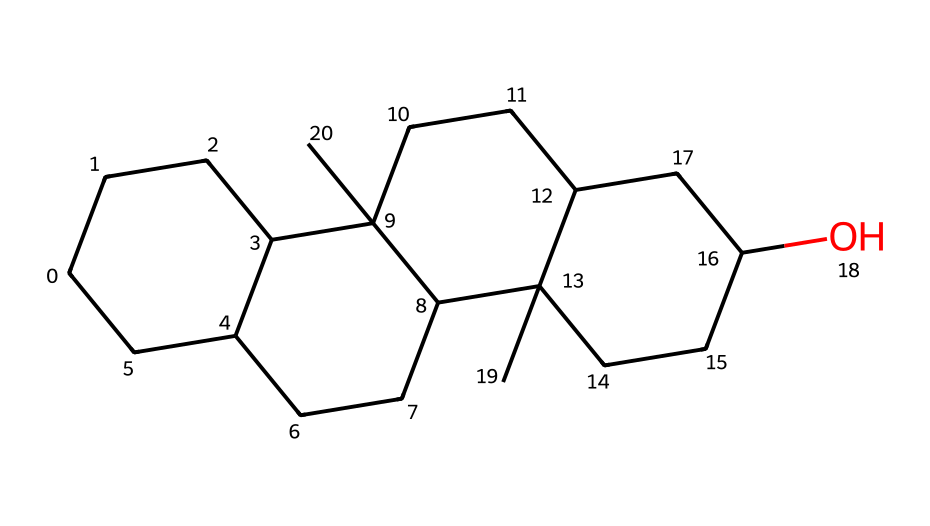What is the molecular formula of cholesterol? To determine the molecular formula, count the number of carbon (C), hydrogen (H), and oxygen (O) atoms in the structure represented by the SMILES. The SMILES indicates a total of 27 carbon atoms, 46 hydrogen atoms, and 1 oxygen atom. Therefore, the molecular formula is C27H46O.
Answer: C27H46O How many rings are present in cholesterol? Examining the cycloalkane structure in the SMILES, we can identify the cyclic portions. Cholesterol has a total of 4 interconnected rings based on the cyclical connectivity within the SMILES representation.
Answer: 4 What type of hydrocarbon is cholesterol? Cholesterol is classified as a sterol, which is a type of steroid. Steroids are characterized by their tetracyclic structure and belong to the family of cycloalkanes due to their circular carbon compositions.
Answer: sterol Which part of cholesterol contributes to its hydrophobic properties? The large hydrocarbon ring structure and the many hydrogen atoms surrounding the carbon skeleton contribute to cholesterol's hydrophobicity. This is due to the predominance of non-polar C-H bonds around the rings.
Answer: hydrocarbon rings Why is the hydroxyl group significant in cholesterol? The hydroxyl group (-OH) is important because it contributes to the molecule’s polarity, allowing cholesterol to interact with both hydrophobic and hydrophilic components of cell membranes. This dual characteristic plays a crucial role in membrane fluidity and stability.
Answer: polarity interaction What is the total number of hydrogen atoms connected to the cycloalkane rings? By analyzing the structure, each cycloalkane ring contributes hydrogen atoms. Totaling the contributions from all rings and accounting for saturation, cholesterol has 46 hydrogen atoms overall. Since there are no other substituents contributing more than the hydroxyl group, we maintain this count.
Answer: 46 